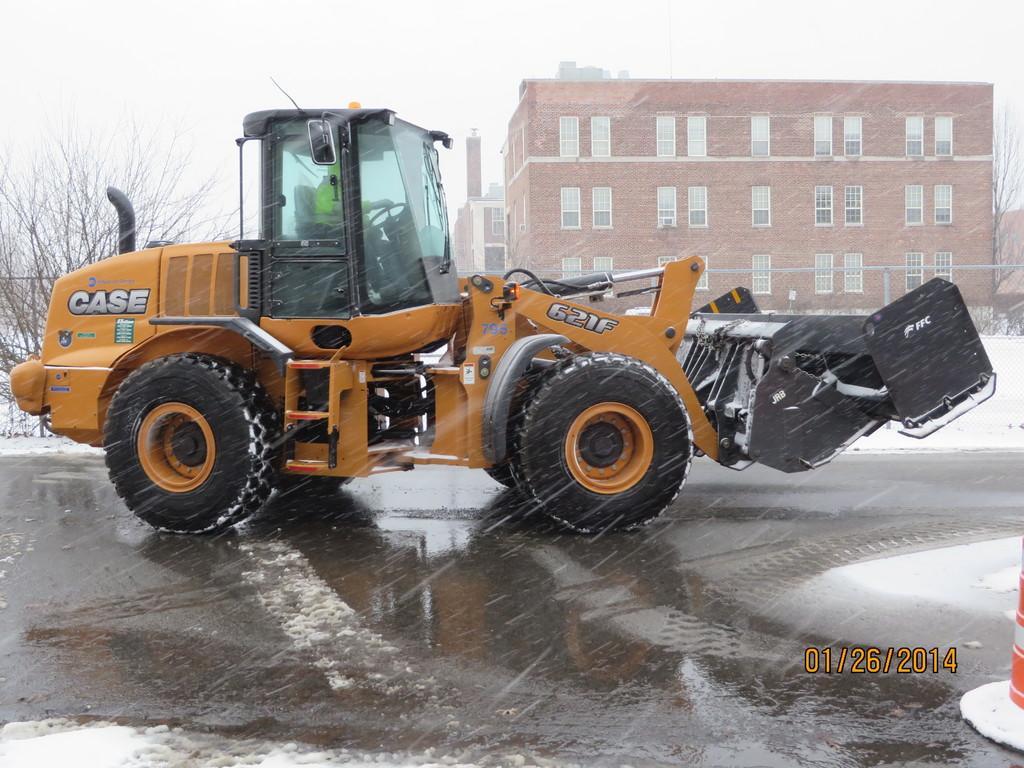Can you describe this image briefly? In this picture there is a person inside a vehicle and we can see road. In the background of the image we can see trees, buildings and sky. In the bottom right side of the image we can see date and an object. 